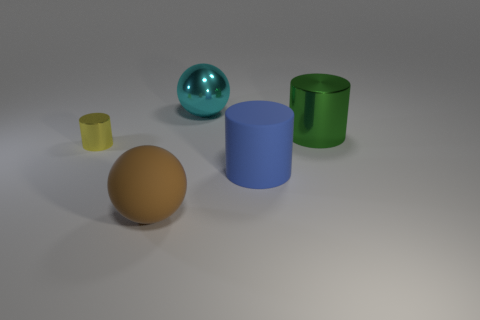Add 1 big purple blocks. How many objects exist? 6 Subtract all big rubber cylinders. How many cylinders are left? 2 Subtract all balls. How many objects are left? 3 Subtract all blue cylinders. How many cylinders are left? 2 Subtract 1 cylinders. How many cylinders are left? 2 Subtract all purple cylinders. Subtract all gray cubes. How many cylinders are left? 3 Subtract all cyan cylinders. How many yellow balls are left? 0 Subtract all tiny red balls. Subtract all green shiny objects. How many objects are left? 4 Add 1 large cylinders. How many large cylinders are left? 3 Add 5 spheres. How many spheres exist? 7 